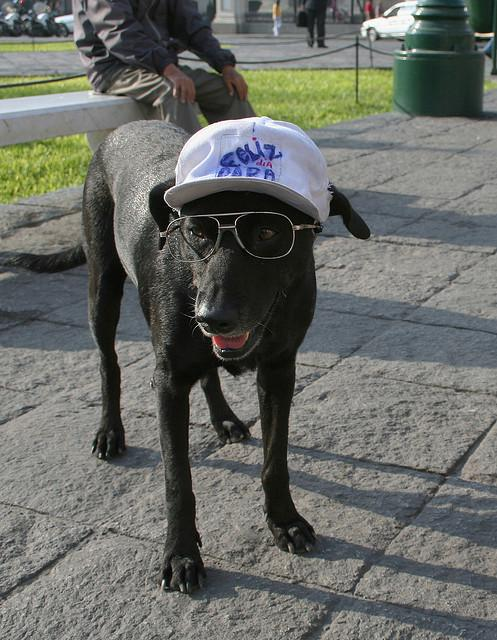What is the dog wearing? hat 